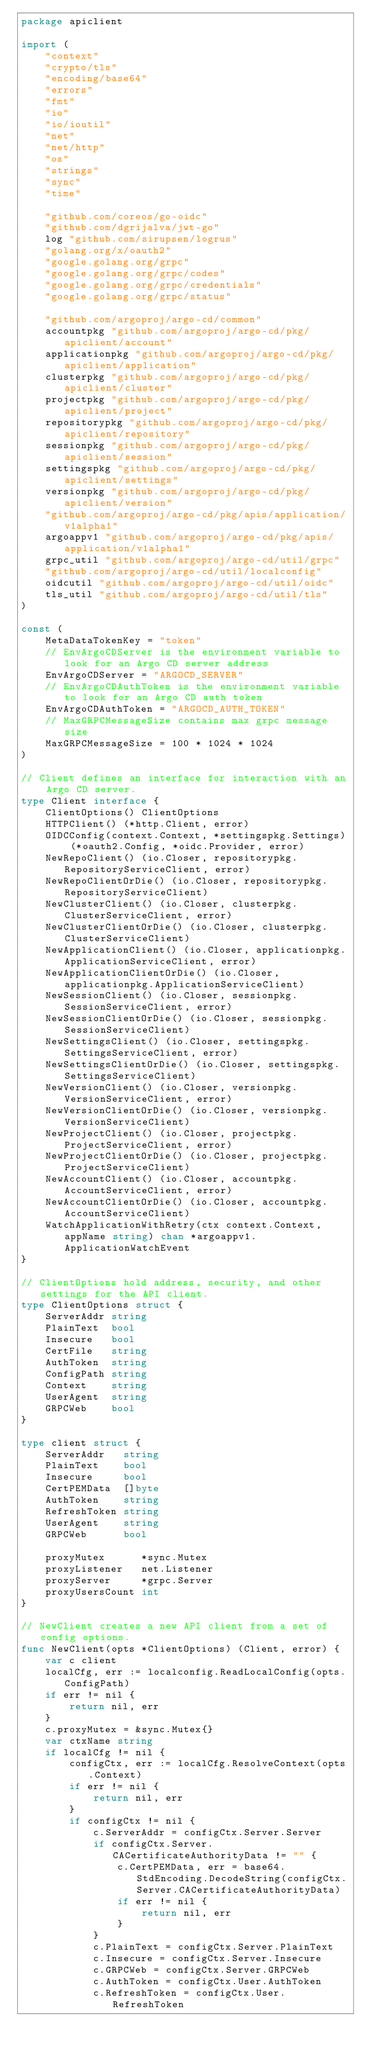<code> <loc_0><loc_0><loc_500><loc_500><_Go_>package apiclient

import (
	"context"
	"crypto/tls"
	"encoding/base64"
	"errors"
	"fmt"
	"io"
	"io/ioutil"
	"net"
	"net/http"
	"os"
	"strings"
	"sync"
	"time"

	"github.com/coreos/go-oidc"
	"github.com/dgrijalva/jwt-go"
	log "github.com/sirupsen/logrus"
	"golang.org/x/oauth2"
	"google.golang.org/grpc"
	"google.golang.org/grpc/codes"
	"google.golang.org/grpc/credentials"
	"google.golang.org/grpc/status"

	"github.com/argoproj/argo-cd/common"
	accountpkg "github.com/argoproj/argo-cd/pkg/apiclient/account"
	applicationpkg "github.com/argoproj/argo-cd/pkg/apiclient/application"
	clusterpkg "github.com/argoproj/argo-cd/pkg/apiclient/cluster"
	projectpkg "github.com/argoproj/argo-cd/pkg/apiclient/project"
	repositorypkg "github.com/argoproj/argo-cd/pkg/apiclient/repository"
	sessionpkg "github.com/argoproj/argo-cd/pkg/apiclient/session"
	settingspkg "github.com/argoproj/argo-cd/pkg/apiclient/settings"
	versionpkg "github.com/argoproj/argo-cd/pkg/apiclient/version"
	"github.com/argoproj/argo-cd/pkg/apis/application/v1alpha1"
	argoappv1 "github.com/argoproj/argo-cd/pkg/apis/application/v1alpha1"
	grpc_util "github.com/argoproj/argo-cd/util/grpc"
	"github.com/argoproj/argo-cd/util/localconfig"
	oidcutil "github.com/argoproj/argo-cd/util/oidc"
	tls_util "github.com/argoproj/argo-cd/util/tls"
)

const (
	MetaDataTokenKey = "token"
	// EnvArgoCDServer is the environment variable to look for an Argo CD server address
	EnvArgoCDServer = "ARGOCD_SERVER"
	// EnvArgoCDAuthToken is the environment variable to look for an Argo CD auth token
	EnvArgoCDAuthToken = "ARGOCD_AUTH_TOKEN"
	// MaxGRPCMessageSize contains max grpc message size
	MaxGRPCMessageSize = 100 * 1024 * 1024
)

// Client defines an interface for interaction with an Argo CD server.
type Client interface {
	ClientOptions() ClientOptions
	HTTPClient() (*http.Client, error)
	OIDCConfig(context.Context, *settingspkg.Settings) (*oauth2.Config, *oidc.Provider, error)
	NewRepoClient() (io.Closer, repositorypkg.RepositoryServiceClient, error)
	NewRepoClientOrDie() (io.Closer, repositorypkg.RepositoryServiceClient)
	NewClusterClient() (io.Closer, clusterpkg.ClusterServiceClient, error)
	NewClusterClientOrDie() (io.Closer, clusterpkg.ClusterServiceClient)
	NewApplicationClient() (io.Closer, applicationpkg.ApplicationServiceClient, error)
	NewApplicationClientOrDie() (io.Closer, applicationpkg.ApplicationServiceClient)
	NewSessionClient() (io.Closer, sessionpkg.SessionServiceClient, error)
	NewSessionClientOrDie() (io.Closer, sessionpkg.SessionServiceClient)
	NewSettingsClient() (io.Closer, settingspkg.SettingsServiceClient, error)
	NewSettingsClientOrDie() (io.Closer, settingspkg.SettingsServiceClient)
	NewVersionClient() (io.Closer, versionpkg.VersionServiceClient, error)
	NewVersionClientOrDie() (io.Closer, versionpkg.VersionServiceClient)
	NewProjectClient() (io.Closer, projectpkg.ProjectServiceClient, error)
	NewProjectClientOrDie() (io.Closer, projectpkg.ProjectServiceClient)
	NewAccountClient() (io.Closer, accountpkg.AccountServiceClient, error)
	NewAccountClientOrDie() (io.Closer, accountpkg.AccountServiceClient)
	WatchApplicationWithRetry(ctx context.Context, appName string) chan *argoappv1.ApplicationWatchEvent
}

// ClientOptions hold address, security, and other settings for the API client.
type ClientOptions struct {
	ServerAddr string
	PlainText  bool
	Insecure   bool
	CertFile   string
	AuthToken  string
	ConfigPath string
	Context    string
	UserAgent  string
	GRPCWeb    bool
}

type client struct {
	ServerAddr   string
	PlainText    bool
	Insecure     bool
	CertPEMData  []byte
	AuthToken    string
	RefreshToken string
	UserAgent    string
	GRPCWeb      bool

	proxyMutex      *sync.Mutex
	proxyListener   net.Listener
	proxyServer     *grpc.Server
	proxyUsersCount int
}

// NewClient creates a new API client from a set of config options.
func NewClient(opts *ClientOptions) (Client, error) {
	var c client
	localCfg, err := localconfig.ReadLocalConfig(opts.ConfigPath)
	if err != nil {
		return nil, err
	}
	c.proxyMutex = &sync.Mutex{}
	var ctxName string
	if localCfg != nil {
		configCtx, err := localCfg.ResolveContext(opts.Context)
		if err != nil {
			return nil, err
		}
		if configCtx != nil {
			c.ServerAddr = configCtx.Server.Server
			if configCtx.Server.CACertificateAuthorityData != "" {
				c.CertPEMData, err = base64.StdEncoding.DecodeString(configCtx.Server.CACertificateAuthorityData)
				if err != nil {
					return nil, err
				}
			}
			c.PlainText = configCtx.Server.PlainText
			c.Insecure = configCtx.Server.Insecure
			c.GRPCWeb = configCtx.Server.GRPCWeb
			c.AuthToken = configCtx.User.AuthToken
			c.RefreshToken = configCtx.User.RefreshToken</code> 